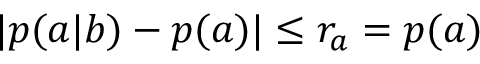<formula> <loc_0><loc_0><loc_500><loc_500>| p ( a | b ) - p ( a ) | \leq r _ { a } = p ( a )</formula> 